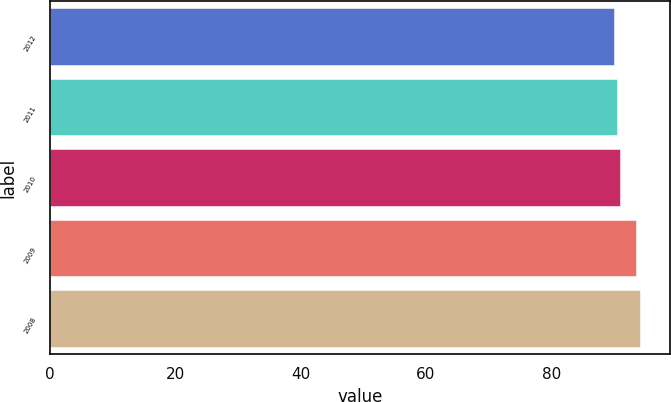<chart> <loc_0><loc_0><loc_500><loc_500><bar_chart><fcel>2012<fcel>2011<fcel>2010<fcel>2009<fcel>2008<nl><fcel>90<fcel>90.42<fcel>90.9<fcel>93.5<fcel>94.2<nl></chart> 